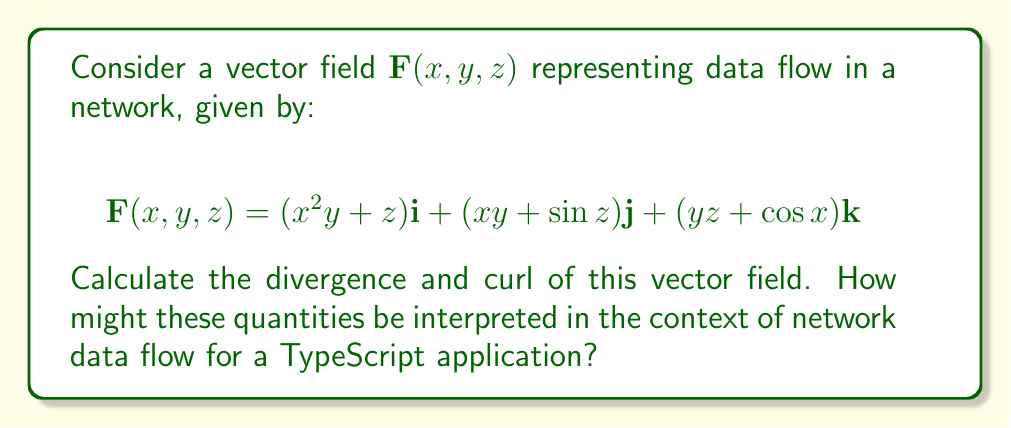Give your solution to this math problem. To solve this problem, we'll calculate the divergence and curl of the given vector field, then interpret the results in the context of network data flow for a TypeScript application.

1. Divergence:
The divergence of a vector field $\mathbf{F}(x, y, z) = P\mathbf{i} + Q\mathbf{j} + R\mathbf{k}$ is given by:

$$\text{div}\mathbf{F} = \nabla \cdot \mathbf{F} = \frac{\partial P}{\partial x} + \frac{\partial Q}{\partial y} + \frac{\partial R}{\partial z}$$

For our vector field:
$P = x^2y + z$
$Q = xy + \sin z$
$R = yz + \cos x$

Calculating partial derivatives:
$\frac{\partial P}{\partial x} = 2xy$
$\frac{\partial Q}{\partial y} = x$
$\frac{\partial R}{\partial z} = y$

Substituting into the divergence formula:
$$\text{div}\mathbf{F} = 2xy + x + y$$

2. Curl:
The curl of a vector field $\mathbf{F}(x, y, z) = P\mathbf{i} + Q\mathbf{j} + R\mathbf{k}$ is given by:

$$\text{curl}\mathbf{F} = \nabla \times \mathbf{F} = \left(\frac{\partial R}{\partial y} - \frac{\partial Q}{\partial z}\right)\mathbf{i} + \left(\frac{\partial P}{\partial z} - \frac{\partial R}{\partial x}\right)\mathbf{j} + \left(\frac{\partial Q}{\partial x} - \frac{\partial P}{\partial y}\right)\mathbf{k}$$

Calculating partial derivatives:
$\frac{\partial R}{\partial y} = z$
$\frac{\partial Q}{\partial z} = \cos z$
$\frac{\partial P}{\partial z} = 1$
$\frac{\partial R}{\partial x} = -\sin x$
$\frac{\partial Q}{\partial x} = y$
$\frac{\partial P}{\partial y} = x^2$

Substituting into the curl formula:
$$\text{curl}\mathbf{F} = (z - \cos z)\mathbf{i} + (1 + \sin x)\mathbf{j} + (y - x^2)\mathbf{k}$$

Interpretation for TypeScript applications:
In the context of network data flow for a TypeScript application:

1. Divergence: The positive divergence $(2xy + x + y)$ indicates that there is a net outflow of data from each point in the network. This could represent data being generated or distributed across the network. In a TypeScript application, this might correspond to the creation of new objects or the spread of information across different components.

2. Curl: The non-zero curl indicates that there is some rotational or circular flow in the data. This could represent cyclic dependencies or feedback loops in the data flow. In a TypeScript application, this might correspond to complex interactions between different modules or components, where data from one part of the system influences another, which in turn affects the original source.

Understanding these concepts can help TypeScript developers optimize data flow in their applications, identify potential bottlenecks or circular dependencies, and design more efficient network architectures.
Answer: Divergence: $\text{div}\mathbf{F} = 2xy + x + y$

Curl: $\text{curl}\mathbf{F} = (z - \cos z)\mathbf{i} + (1 + \sin x)\mathbf{j} + (y - x^2)\mathbf{k}$ 